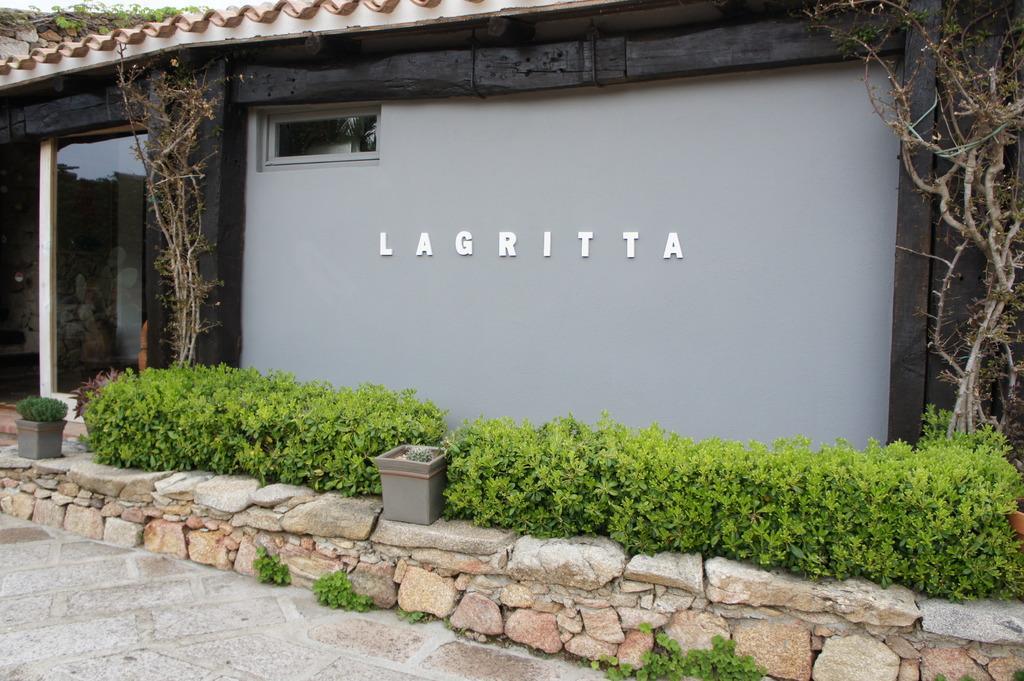In one or two sentences, can you explain what this image depicts? We can see stones, plants, pots, trees, house, glass, window and some text on a wall. 